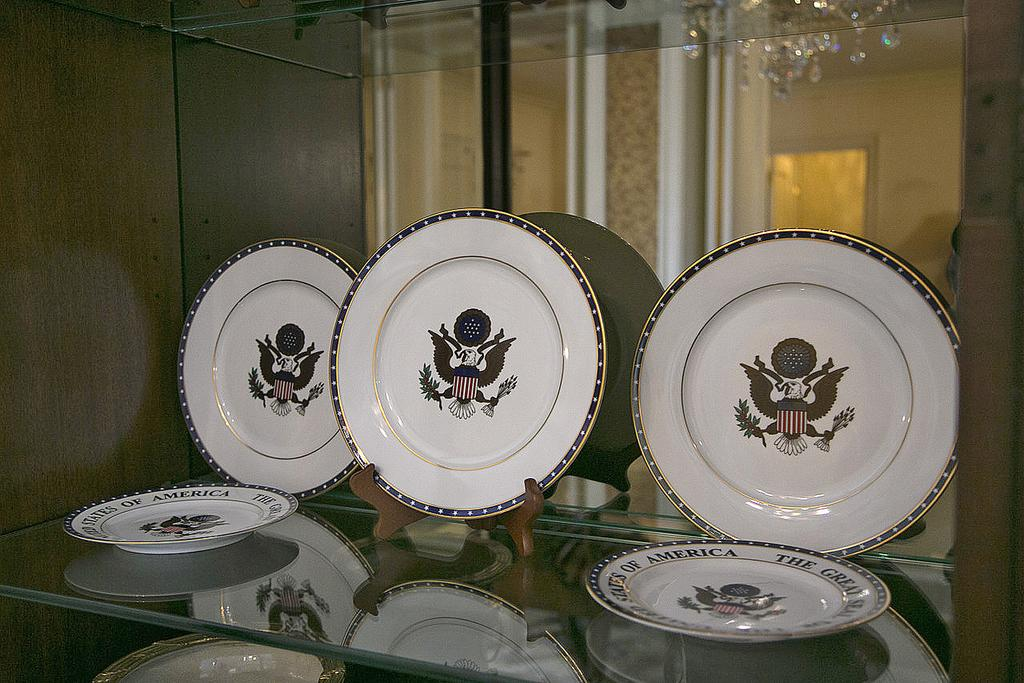What objects are on the glass rack at the bottom of the image? There are plates with images on the glass rack at the bottom of the image. What architectural features can be seen in the image? Pillars and walls are visible in the image. What type of lighting fixture is present in the image? There is a chandelier in the image. What type of bone can be seen in the image? There is no bone present in the image. What caption is written on the plates in the image? The provided facts do not mention any captions on the plates, so we cannot determine the content of any captions. 